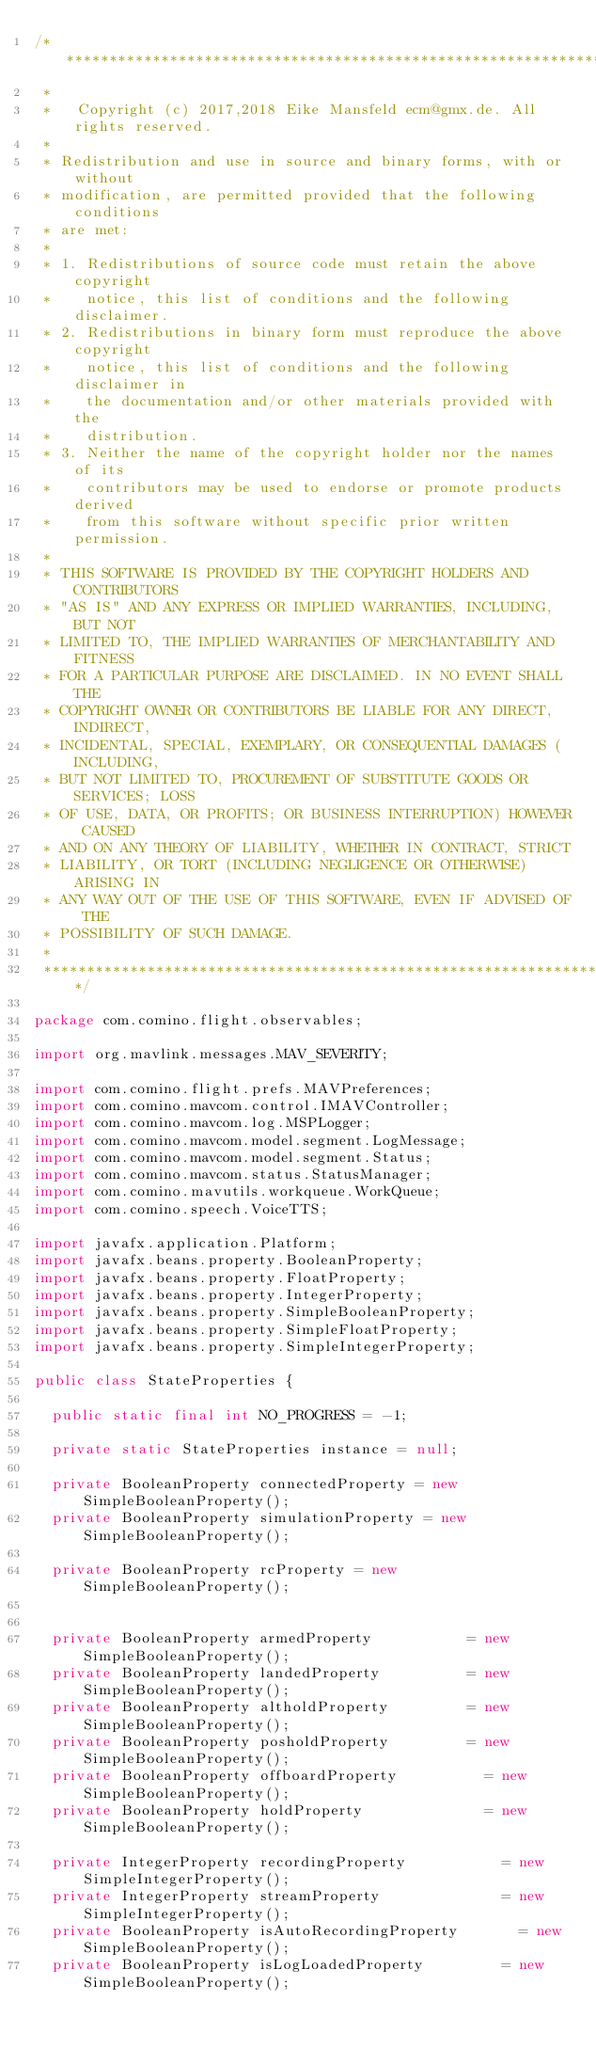Convert code to text. <code><loc_0><loc_0><loc_500><loc_500><_Java_>/****************************************************************************
 *
 *   Copyright (c) 2017,2018 Eike Mansfeld ecm@gmx.de. All rights reserved.
 *
 * Redistribution and use in source and binary forms, with or without
 * modification, are permitted provided that the following conditions
 * are met:
 *
 * 1. Redistributions of source code must retain the above copyright
 *    notice, this list of conditions and the following disclaimer.
 * 2. Redistributions in binary form must reproduce the above copyright
 *    notice, this list of conditions and the following disclaimer in
 *    the documentation and/or other materials provided with the
 *    distribution.
 * 3. Neither the name of the copyright holder nor the names of its
 *    contributors may be used to endorse or promote products derived
 *    from this software without specific prior written permission.
 *
 * THIS SOFTWARE IS PROVIDED BY THE COPYRIGHT HOLDERS AND CONTRIBUTORS
 * "AS IS" AND ANY EXPRESS OR IMPLIED WARRANTIES, INCLUDING, BUT NOT
 * LIMITED TO, THE IMPLIED WARRANTIES OF MERCHANTABILITY AND FITNESS
 * FOR A PARTICULAR PURPOSE ARE DISCLAIMED. IN NO EVENT SHALL THE
 * COPYRIGHT OWNER OR CONTRIBUTORS BE LIABLE FOR ANY DIRECT, INDIRECT,
 * INCIDENTAL, SPECIAL, EXEMPLARY, OR CONSEQUENTIAL DAMAGES (INCLUDING,
 * BUT NOT LIMITED TO, PROCUREMENT OF SUBSTITUTE GOODS OR SERVICES; LOSS
 * OF USE, DATA, OR PROFITS; OR BUSINESS INTERRUPTION) HOWEVER CAUSED
 * AND ON ANY THEORY OF LIABILITY, WHETHER IN CONTRACT, STRICT
 * LIABILITY, OR TORT (INCLUDING NEGLIGENCE OR OTHERWISE) ARISING IN
 * ANY WAY OUT OF THE USE OF THIS SOFTWARE, EVEN IF ADVISED OF THE
 * POSSIBILITY OF SUCH DAMAGE.
 *
 ****************************************************************************/

package com.comino.flight.observables;

import org.mavlink.messages.MAV_SEVERITY;

import com.comino.flight.prefs.MAVPreferences;
import com.comino.mavcom.control.IMAVController;
import com.comino.mavcom.log.MSPLogger;
import com.comino.mavcom.model.segment.LogMessage;
import com.comino.mavcom.model.segment.Status;
import com.comino.mavcom.status.StatusManager;
import com.comino.mavutils.workqueue.WorkQueue;
import com.comino.speech.VoiceTTS;

import javafx.application.Platform;
import javafx.beans.property.BooleanProperty;
import javafx.beans.property.FloatProperty;
import javafx.beans.property.IntegerProperty;
import javafx.beans.property.SimpleBooleanProperty;
import javafx.beans.property.SimpleFloatProperty;
import javafx.beans.property.SimpleIntegerProperty;

public class StateProperties {

	public static final int NO_PROGRESS = -1;

	private static StateProperties instance = null;

	private BooleanProperty connectedProperty = new SimpleBooleanProperty();
	private BooleanProperty simulationProperty = new SimpleBooleanProperty();

	private BooleanProperty rcProperty = new SimpleBooleanProperty();


	private BooleanProperty armedProperty 					= new SimpleBooleanProperty();
	private BooleanProperty landedProperty 					= new SimpleBooleanProperty();
	private BooleanProperty altholdProperty 				= new SimpleBooleanProperty();
	private BooleanProperty posholdProperty 				= new SimpleBooleanProperty();
	private BooleanProperty offboardProperty 			    = new SimpleBooleanProperty();
	private BooleanProperty holdProperty 			        = new SimpleBooleanProperty();

	private IntegerProperty recordingProperty     			= new SimpleIntegerProperty();
	private IntegerProperty streamProperty     		    	= new SimpleIntegerProperty();
	private BooleanProperty isAutoRecordingProperty    		= new SimpleBooleanProperty();
	private BooleanProperty isLogLoadedProperty   			= new SimpleBooleanProperty();</code> 